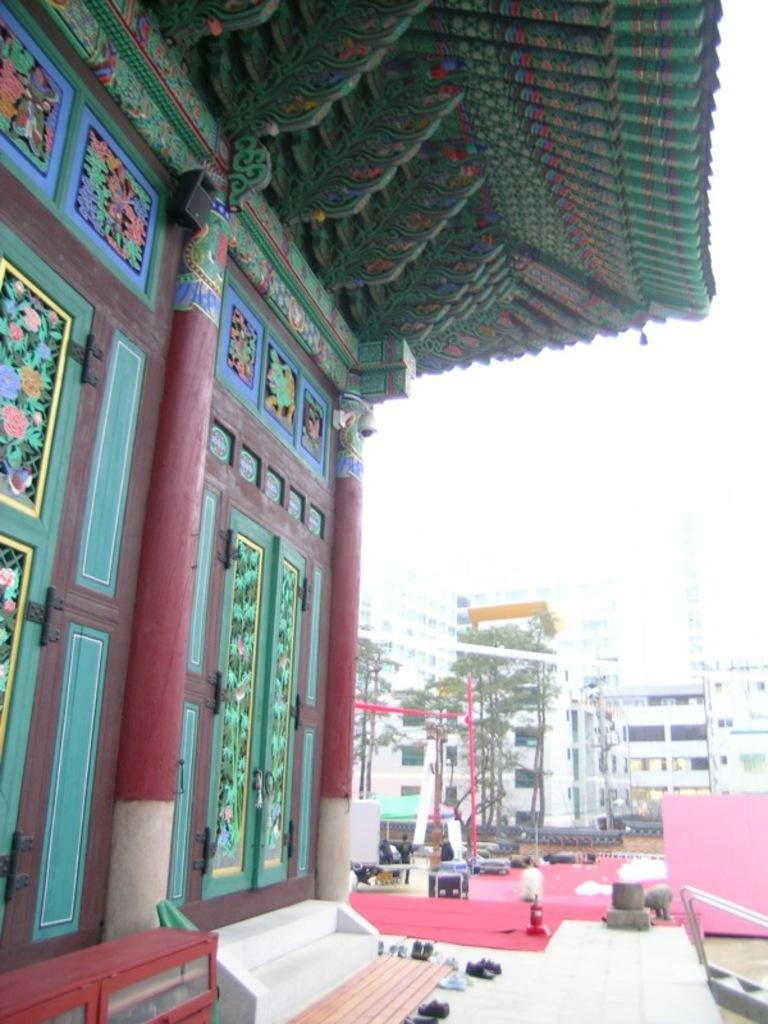What type of natural elements can be seen in the image? There are trees in the image. What type of man-made structures are present in the image? There are buildings, a staircase, a door, and a pillar in the image. What part of the natural environment is visible in the image? The sky is visible in the image. What type of comb is being used to style the trees in the image? There is no comb present in the image, and the trees are not being styled. What type of badge is visible on the door in the image? There is no badge present on the door in the image. 